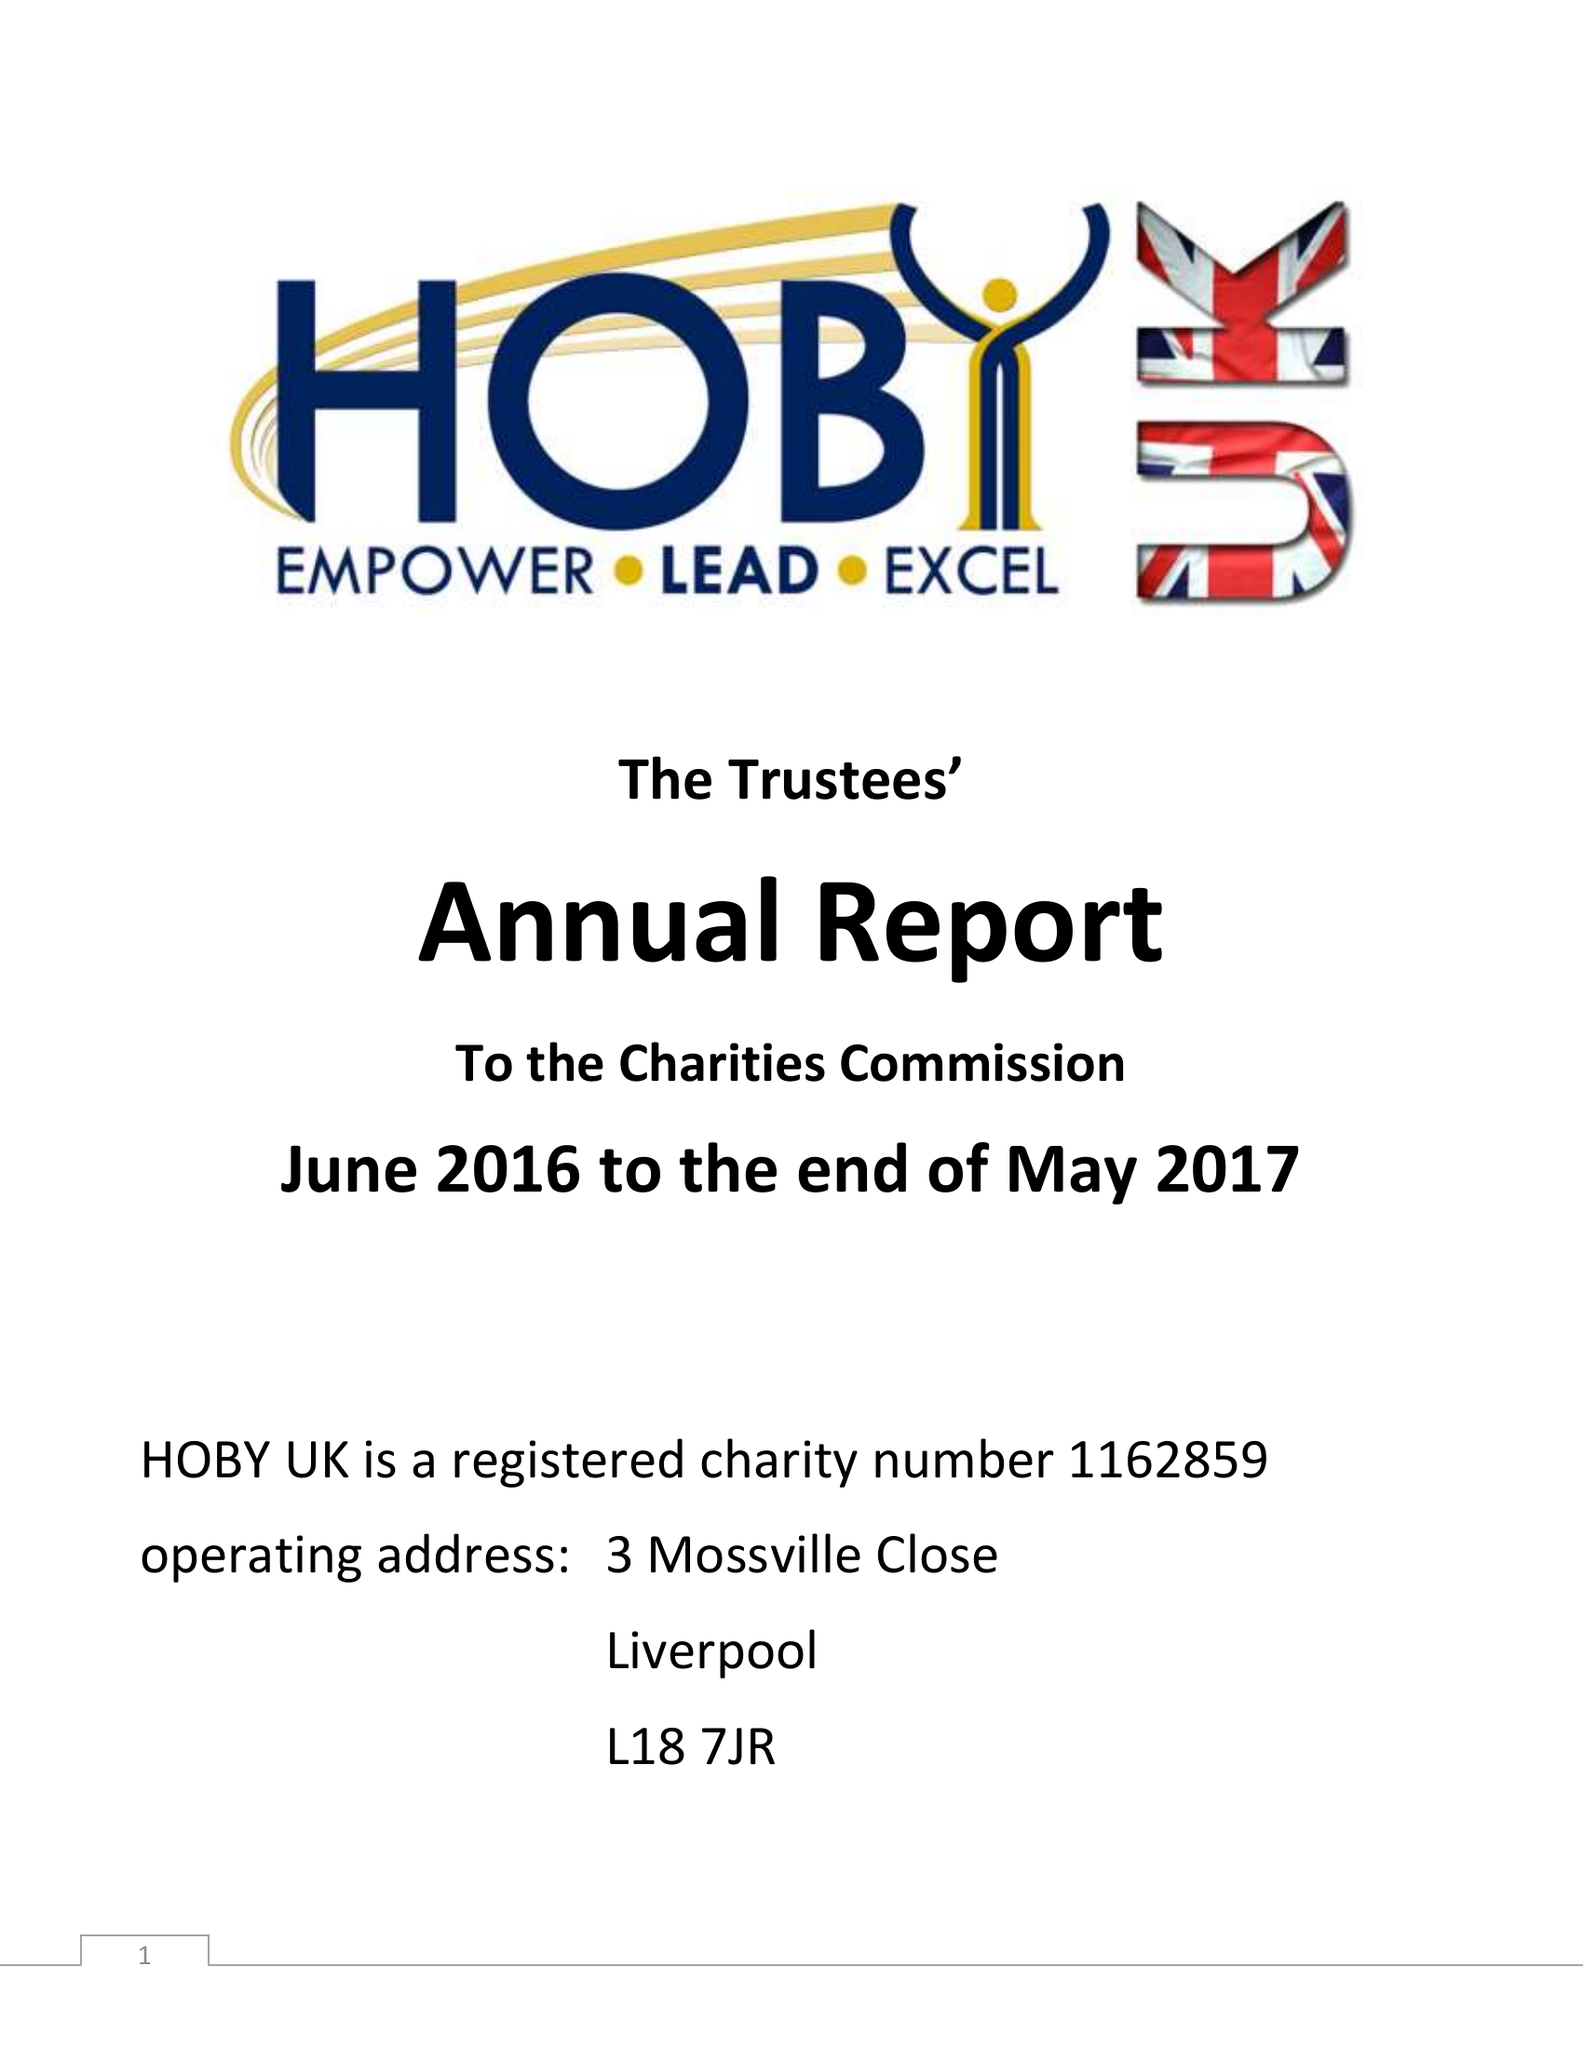What is the value for the income_annually_in_british_pounds?
Answer the question using a single word or phrase. 15138.40 